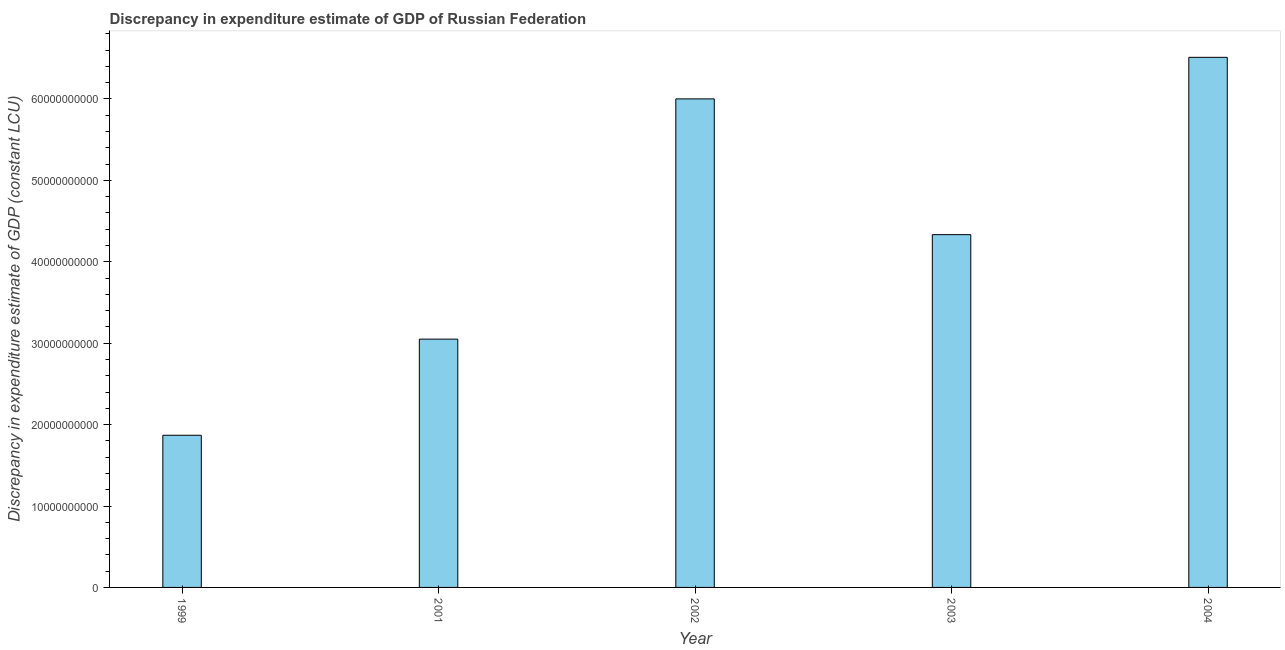Does the graph contain grids?
Provide a succinct answer. No. What is the title of the graph?
Provide a succinct answer. Discrepancy in expenditure estimate of GDP of Russian Federation. What is the label or title of the Y-axis?
Keep it short and to the point. Discrepancy in expenditure estimate of GDP (constant LCU). What is the discrepancy in expenditure estimate of gdp in 2001?
Give a very brief answer. 3.05e+1. Across all years, what is the maximum discrepancy in expenditure estimate of gdp?
Give a very brief answer. 6.51e+1. Across all years, what is the minimum discrepancy in expenditure estimate of gdp?
Your answer should be very brief. 1.87e+1. In which year was the discrepancy in expenditure estimate of gdp maximum?
Keep it short and to the point. 2004. In which year was the discrepancy in expenditure estimate of gdp minimum?
Keep it short and to the point. 1999. What is the sum of the discrepancy in expenditure estimate of gdp?
Give a very brief answer. 2.18e+11. What is the difference between the discrepancy in expenditure estimate of gdp in 2002 and 2003?
Provide a succinct answer. 1.67e+1. What is the average discrepancy in expenditure estimate of gdp per year?
Give a very brief answer. 4.35e+1. What is the median discrepancy in expenditure estimate of gdp?
Offer a terse response. 4.33e+1. What is the ratio of the discrepancy in expenditure estimate of gdp in 1999 to that in 2001?
Offer a terse response. 0.61. Is the discrepancy in expenditure estimate of gdp in 1999 less than that in 2004?
Your answer should be very brief. Yes. Is the difference between the discrepancy in expenditure estimate of gdp in 1999 and 2003 greater than the difference between any two years?
Provide a short and direct response. No. What is the difference between the highest and the second highest discrepancy in expenditure estimate of gdp?
Give a very brief answer. 5.10e+09. What is the difference between the highest and the lowest discrepancy in expenditure estimate of gdp?
Provide a succinct answer. 4.64e+1. How many bars are there?
Provide a short and direct response. 5. Are all the bars in the graph horizontal?
Give a very brief answer. No. How many years are there in the graph?
Provide a succinct answer. 5. What is the difference between two consecutive major ticks on the Y-axis?
Provide a succinct answer. 1.00e+1. Are the values on the major ticks of Y-axis written in scientific E-notation?
Your response must be concise. No. What is the Discrepancy in expenditure estimate of GDP (constant LCU) of 1999?
Give a very brief answer. 1.87e+1. What is the Discrepancy in expenditure estimate of GDP (constant LCU) in 2001?
Provide a succinct answer. 3.05e+1. What is the Discrepancy in expenditure estimate of GDP (constant LCU) in 2002?
Ensure brevity in your answer.  6.00e+1. What is the Discrepancy in expenditure estimate of GDP (constant LCU) in 2003?
Your response must be concise. 4.33e+1. What is the Discrepancy in expenditure estimate of GDP (constant LCU) of 2004?
Offer a terse response. 6.51e+1. What is the difference between the Discrepancy in expenditure estimate of GDP (constant LCU) in 1999 and 2001?
Ensure brevity in your answer.  -1.18e+1. What is the difference between the Discrepancy in expenditure estimate of GDP (constant LCU) in 1999 and 2002?
Give a very brief answer. -4.13e+1. What is the difference between the Discrepancy in expenditure estimate of GDP (constant LCU) in 1999 and 2003?
Ensure brevity in your answer.  -2.46e+1. What is the difference between the Discrepancy in expenditure estimate of GDP (constant LCU) in 1999 and 2004?
Your answer should be very brief. -4.64e+1. What is the difference between the Discrepancy in expenditure estimate of GDP (constant LCU) in 2001 and 2002?
Provide a succinct answer. -2.95e+1. What is the difference between the Discrepancy in expenditure estimate of GDP (constant LCU) in 2001 and 2003?
Offer a very short reply. -1.28e+1. What is the difference between the Discrepancy in expenditure estimate of GDP (constant LCU) in 2001 and 2004?
Your response must be concise. -3.46e+1. What is the difference between the Discrepancy in expenditure estimate of GDP (constant LCU) in 2002 and 2003?
Offer a very short reply. 1.67e+1. What is the difference between the Discrepancy in expenditure estimate of GDP (constant LCU) in 2002 and 2004?
Your response must be concise. -5.10e+09. What is the difference between the Discrepancy in expenditure estimate of GDP (constant LCU) in 2003 and 2004?
Your response must be concise. -2.18e+1. What is the ratio of the Discrepancy in expenditure estimate of GDP (constant LCU) in 1999 to that in 2001?
Your response must be concise. 0.61. What is the ratio of the Discrepancy in expenditure estimate of GDP (constant LCU) in 1999 to that in 2002?
Provide a short and direct response. 0.31. What is the ratio of the Discrepancy in expenditure estimate of GDP (constant LCU) in 1999 to that in 2003?
Offer a terse response. 0.43. What is the ratio of the Discrepancy in expenditure estimate of GDP (constant LCU) in 1999 to that in 2004?
Your answer should be very brief. 0.29. What is the ratio of the Discrepancy in expenditure estimate of GDP (constant LCU) in 2001 to that in 2002?
Your answer should be very brief. 0.51. What is the ratio of the Discrepancy in expenditure estimate of GDP (constant LCU) in 2001 to that in 2003?
Provide a succinct answer. 0.7. What is the ratio of the Discrepancy in expenditure estimate of GDP (constant LCU) in 2001 to that in 2004?
Ensure brevity in your answer.  0.47. What is the ratio of the Discrepancy in expenditure estimate of GDP (constant LCU) in 2002 to that in 2003?
Give a very brief answer. 1.39. What is the ratio of the Discrepancy in expenditure estimate of GDP (constant LCU) in 2002 to that in 2004?
Your answer should be very brief. 0.92. What is the ratio of the Discrepancy in expenditure estimate of GDP (constant LCU) in 2003 to that in 2004?
Ensure brevity in your answer.  0.67. 